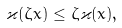<formula> <loc_0><loc_0><loc_500><loc_500>\varkappa ( \zeta x ) \leq \zeta \varkappa ( x ) ,</formula> 